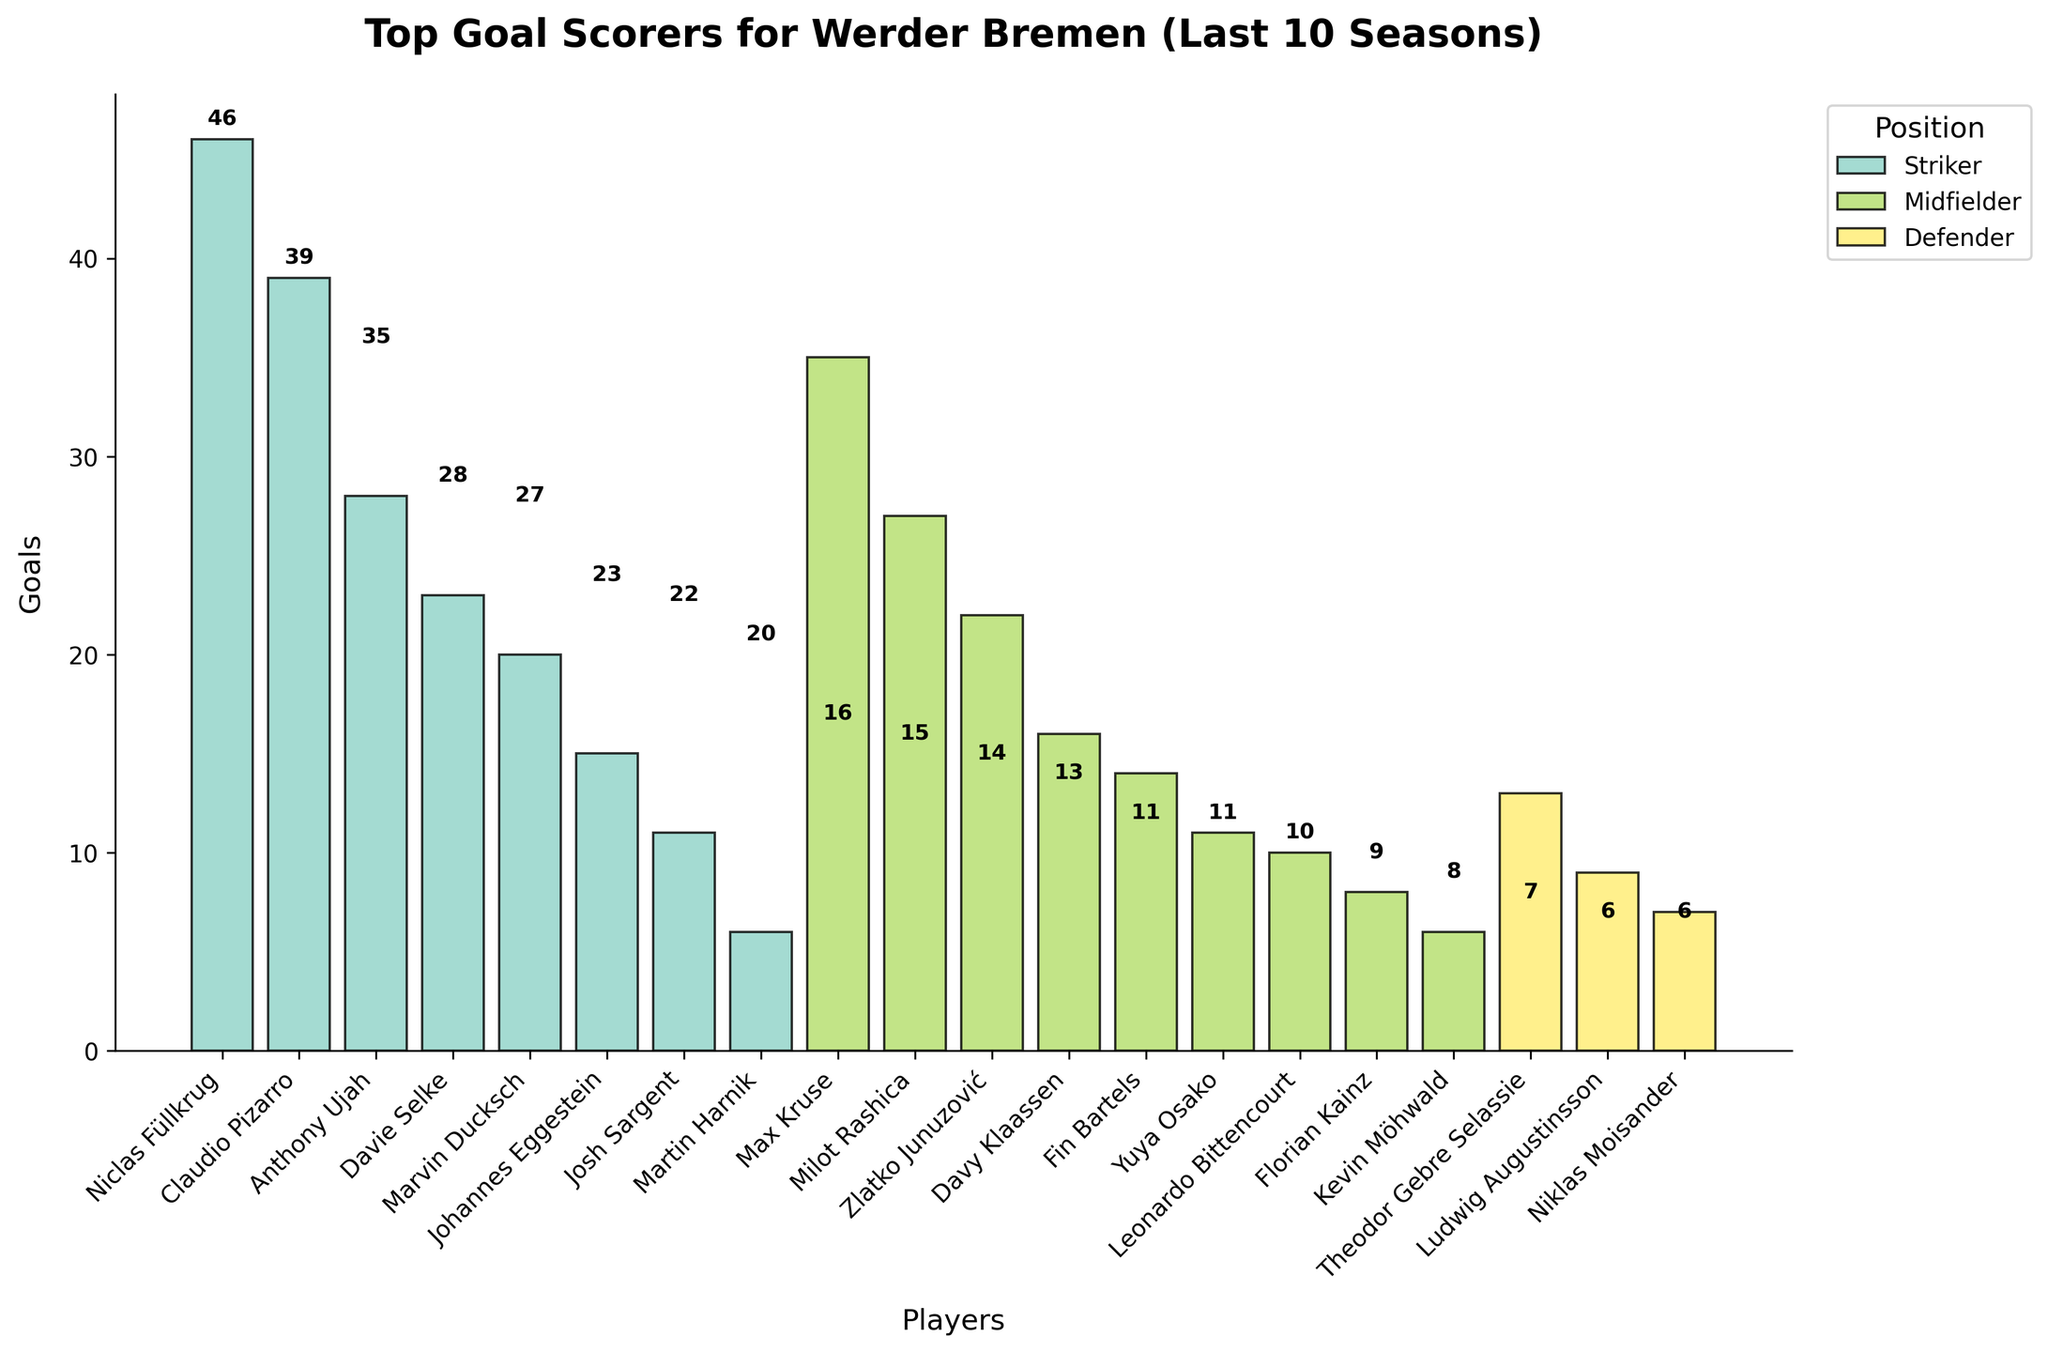Which striker has scored the most goals for Werder Bremen in the last 10 seasons? In the bar chart, each player's goals are displayed with their respective positions. Looking at the strikers' goals, Niclas Füllkrug has the highest number of goals, with 46 goals to his name.
Answer: Niclas Füllkrug Which midfielder has the least goals, and how many did he score? To find the midfielder with the least goals, look at the heights of the bars labeled "Midfielder." Kevin Möhwald has the shortest bar among midfielders, indicating he scored the least goals.
Answer: Kevin Möhwald, 6 How many goals did Davie Selke and Marvin Ducksch score combined? Find the bars representing Davie Selke and Marvin Ducksch, both strikers, and add their goals together. Selke scored 23 goals, and Ducksch scored 20 goals. Adding them up gives 23 + 20 = 43 goals.
Answer: 43 Are any defenders among the top 10 goal scorers? Observe the bars labeled "Defender." The two highest scoring defenders are Theodor Gebre Selassie with 13 goals and Ludwig Augustinsson with 9 goals. Comparing these figures to the top 10 goal scorers, none of these defenders make it to the top 10.
Answer: No Compare Niclas Füllkrug and Claudio Pizarro’s goals. Who scored more, and by how much? Locate the bars for Niclas Füllkrug and Claudio Pizarro. Füllkrug has 46 goals, and Pizarro has 39 goals. Calculate the difference: 46 - 39 = 7 goals.
Answer: Niclas Füllkrug, by 7 goals Which position has contributed more overall goals, midfielders or strikers? Sum the goals of all players identified as midfielders and those identified as strikers. Midfielders: Max Kruse (35) + Milot Rashica (27) + Zlatko Junuzović (22) + Davy Klaassen (16) + Fin Bartels (14) + Yuya Osako (11) + Leonardo Bittencourt (10) + Florian Kainz (8) + Kevin Möhwald (6) = 149. Strikers: Niclas Füllkrug (46) + Claudio Pizarro (39) + Anthony Ujah (28) + Davie Selke (23) + Marvin Ducksch (20) + Johannes Eggestein (15) + Josh Sargent (11) + Martin Harnik (6) = 188.
Answer: Strikers Which player scored exactly 11 goals, and what position does he play? Look for the bars corresponding to 11 goals. Two players scored exactly 11 goals: Yuya Osako (Midfielder) and Josh Sargent (Striker).
Answer: Yuya Osako (Midfielder), Josh Sargent (Striker) What is the total number of goals scored by the top 5 goal scorers? Identify the top 5 goal scorers by the heights of the bars: Niclas Füllkrug (46), Claudio Pizarro (39), Max Kruse (35), Anthony Ujah (28), and Milot Rashica (27). Adding them together provides the total: 46 + 39 + 35 + 28 + 27 = 175 goals.
Answer: 175 Which defender scored the most goals, and how many did he score? Among the defenders, compare the bars' heights. Theodor Gebre Selassie has the highest bar, indicating the most goals. He scored 13 goals.
Answer: Theodor Gebre Selassie, 13 